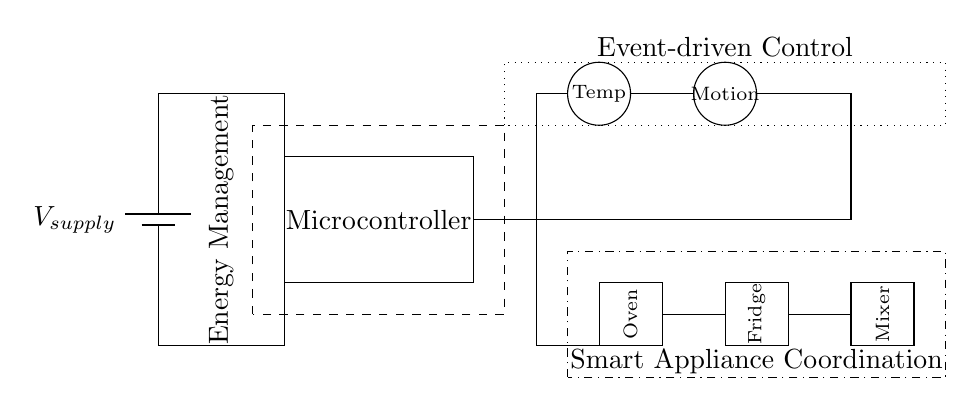What type of power supply is used? The circuit uses a battery as the power supply, indicated by the symbol in the top left corner labeled V_supply.
Answer: Battery What is the main function of the microcontroller? The microcontroller serves as the central control unit, processing inputs from sensors and coordinating appliance operations based on those inputs.
Answer: Control How many sensors are included in the circuit? There are two sensors depicted at the top, one for temperature and one for motion, which can be counted from their symbols.
Answer: Two What components are included for energy management? The dashed rectangle labeled Energy Management encompasses the microcontroller and is responsible for managing and distributing power efficiently among the appliances.
Answer: Microcontroller What type of control is being implemented in this circuit? The circuit implements an event-driven control method, which is shown by the dotted rectangle surrounding the microcontroller and appliances, meaning the actions are initiated by specific events such as sensor readings.
Answer: Event-driven Which appliances are included in the circuit? The appliances represented are an oven, a fridge, and a mixer, which are labeled at the bottom of the circuit diagram.
Answer: Oven, Fridge, Mixer How are the sensors connected to the microcontroller? The connections are illustrated with lines leading from each sensor directly to the microcontroller, indicating that they feed information into the microcontroller for processing.
Answer: Directly 